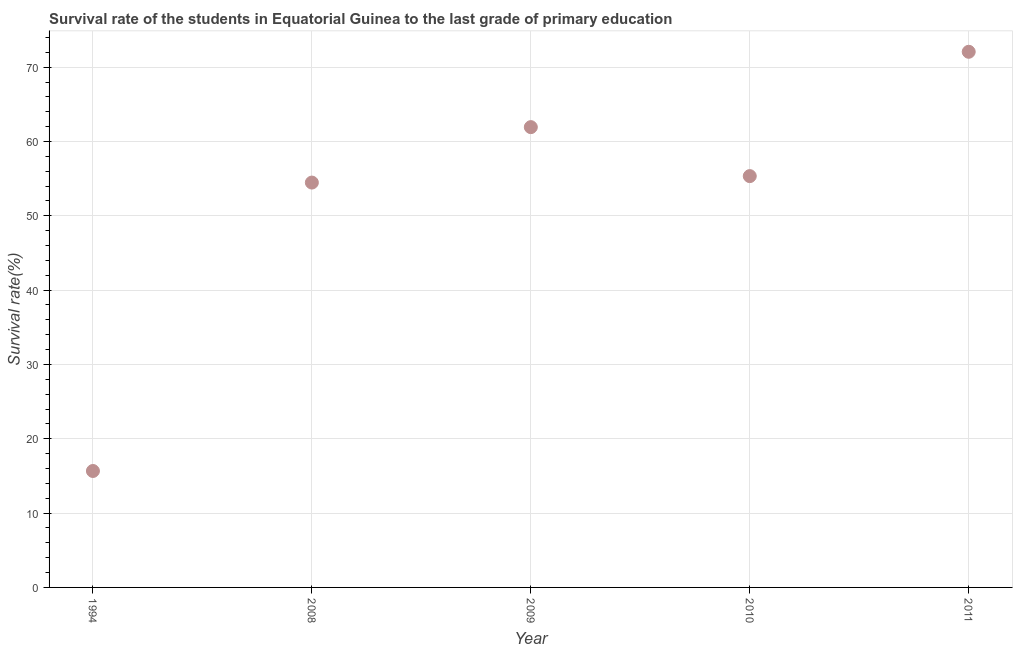What is the survival rate in primary education in 1994?
Your answer should be very brief. 15.67. Across all years, what is the maximum survival rate in primary education?
Make the answer very short. 72.07. Across all years, what is the minimum survival rate in primary education?
Give a very brief answer. 15.67. What is the sum of the survival rate in primary education?
Provide a short and direct response. 259.48. What is the difference between the survival rate in primary education in 1994 and 2011?
Offer a very short reply. -56.4. What is the average survival rate in primary education per year?
Provide a succinct answer. 51.9. What is the median survival rate in primary education?
Offer a very short reply. 55.34. In how many years, is the survival rate in primary education greater than 56 %?
Ensure brevity in your answer.  2. Do a majority of the years between 2009 and 1994 (inclusive) have survival rate in primary education greater than 48 %?
Make the answer very short. No. What is the ratio of the survival rate in primary education in 2008 to that in 2010?
Your answer should be compact. 0.98. Is the survival rate in primary education in 1994 less than that in 2009?
Give a very brief answer. Yes. Is the difference between the survival rate in primary education in 2009 and 2011 greater than the difference between any two years?
Provide a short and direct response. No. What is the difference between the highest and the second highest survival rate in primary education?
Make the answer very short. 10.14. What is the difference between the highest and the lowest survival rate in primary education?
Make the answer very short. 56.4. In how many years, is the survival rate in primary education greater than the average survival rate in primary education taken over all years?
Give a very brief answer. 4. How many dotlines are there?
Your answer should be very brief. 1. What is the difference between two consecutive major ticks on the Y-axis?
Give a very brief answer. 10. Are the values on the major ticks of Y-axis written in scientific E-notation?
Make the answer very short. No. Does the graph contain grids?
Your answer should be very brief. Yes. What is the title of the graph?
Provide a short and direct response. Survival rate of the students in Equatorial Guinea to the last grade of primary education. What is the label or title of the X-axis?
Provide a succinct answer. Year. What is the label or title of the Y-axis?
Your answer should be very brief. Survival rate(%). What is the Survival rate(%) in 1994?
Provide a succinct answer. 15.67. What is the Survival rate(%) in 2008?
Your answer should be compact. 54.47. What is the Survival rate(%) in 2009?
Make the answer very short. 61.93. What is the Survival rate(%) in 2010?
Make the answer very short. 55.34. What is the Survival rate(%) in 2011?
Provide a short and direct response. 72.07. What is the difference between the Survival rate(%) in 1994 and 2008?
Provide a short and direct response. -38.81. What is the difference between the Survival rate(%) in 1994 and 2009?
Provide a succinct answer. -46.27. What is the difference between the Survival rate(%) in 1994 and 2010?
Offer a terse response. -39.68. What is the difference between the Survival rate(%) in 1994 and 2011?
Your response must be concise. -56.4. What is the difference between the Survival rate(%) in 2008 and 2009?
Your answer should be compact. -7.46. What is the difference between the Survival rate(%) in 2008 and 2010?
Your response must be concise. -0.87. What is the difference between the Survival rate(%) in 2008 and 2011?
Your answer should be very brief. -17.6. What is the difference between the Survival rate(%) in 2009 and 2010?
Offer a very short reply. 6.59. What is the difference between the Survival rate(%) in 2009 and 2011?
Give a very brief answer. -10.14. What is the difference between the Survival rate(%) in 2010 and 2011?
Ensure brevity in your answer.  -16.73. What is the ratio of the Survival rate(%) in 1994 to that in 2008?
Make the answer very short. 0.29. What is the ratio of the Survival rate(%) in 1994 to that in 2009?
Your answer should be very brief. 0.25. What is the ratio of the Survival rate(%) in 1994 to that in 2010?
Your response must be concise. 0.28. What is the ratio of the Survival rate(%) in 1994 to that in 2011?
Provide a succinct answer. 0.22. What is the ratio of the Survival rate(%) in 2008 to that in 2010?
Give a very brief answer. 0.98. What is the ratio of the Survival rate(%) in 2008 to that in 2011?
Keep it short and to the point. 0.76. What is the ratio of the Survival rate(%) in 2009 to that in 2010?
Make the answer very short. 1.12. What is the ratio of the Survival rate(%) in 2009 to that in 2011?
Ensure brevity in your answer.  0.86. What is the ratio of the Survival rate(%) in 2010 to that in 2011?
Provide a succinct answer. 0.77. 